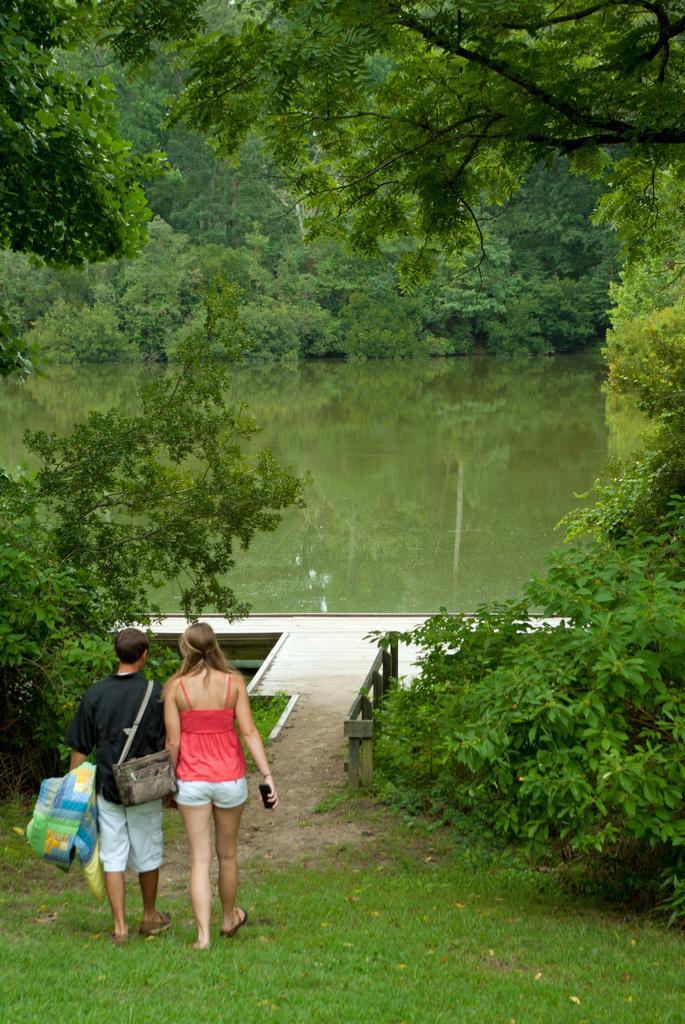Please provide a concise description of this image. In this image, we can see a man wearing bag and holding an object in his hand and there is a lady holding mobile in her hand and in the center, we can see a pond. In the background, there are many trees. 